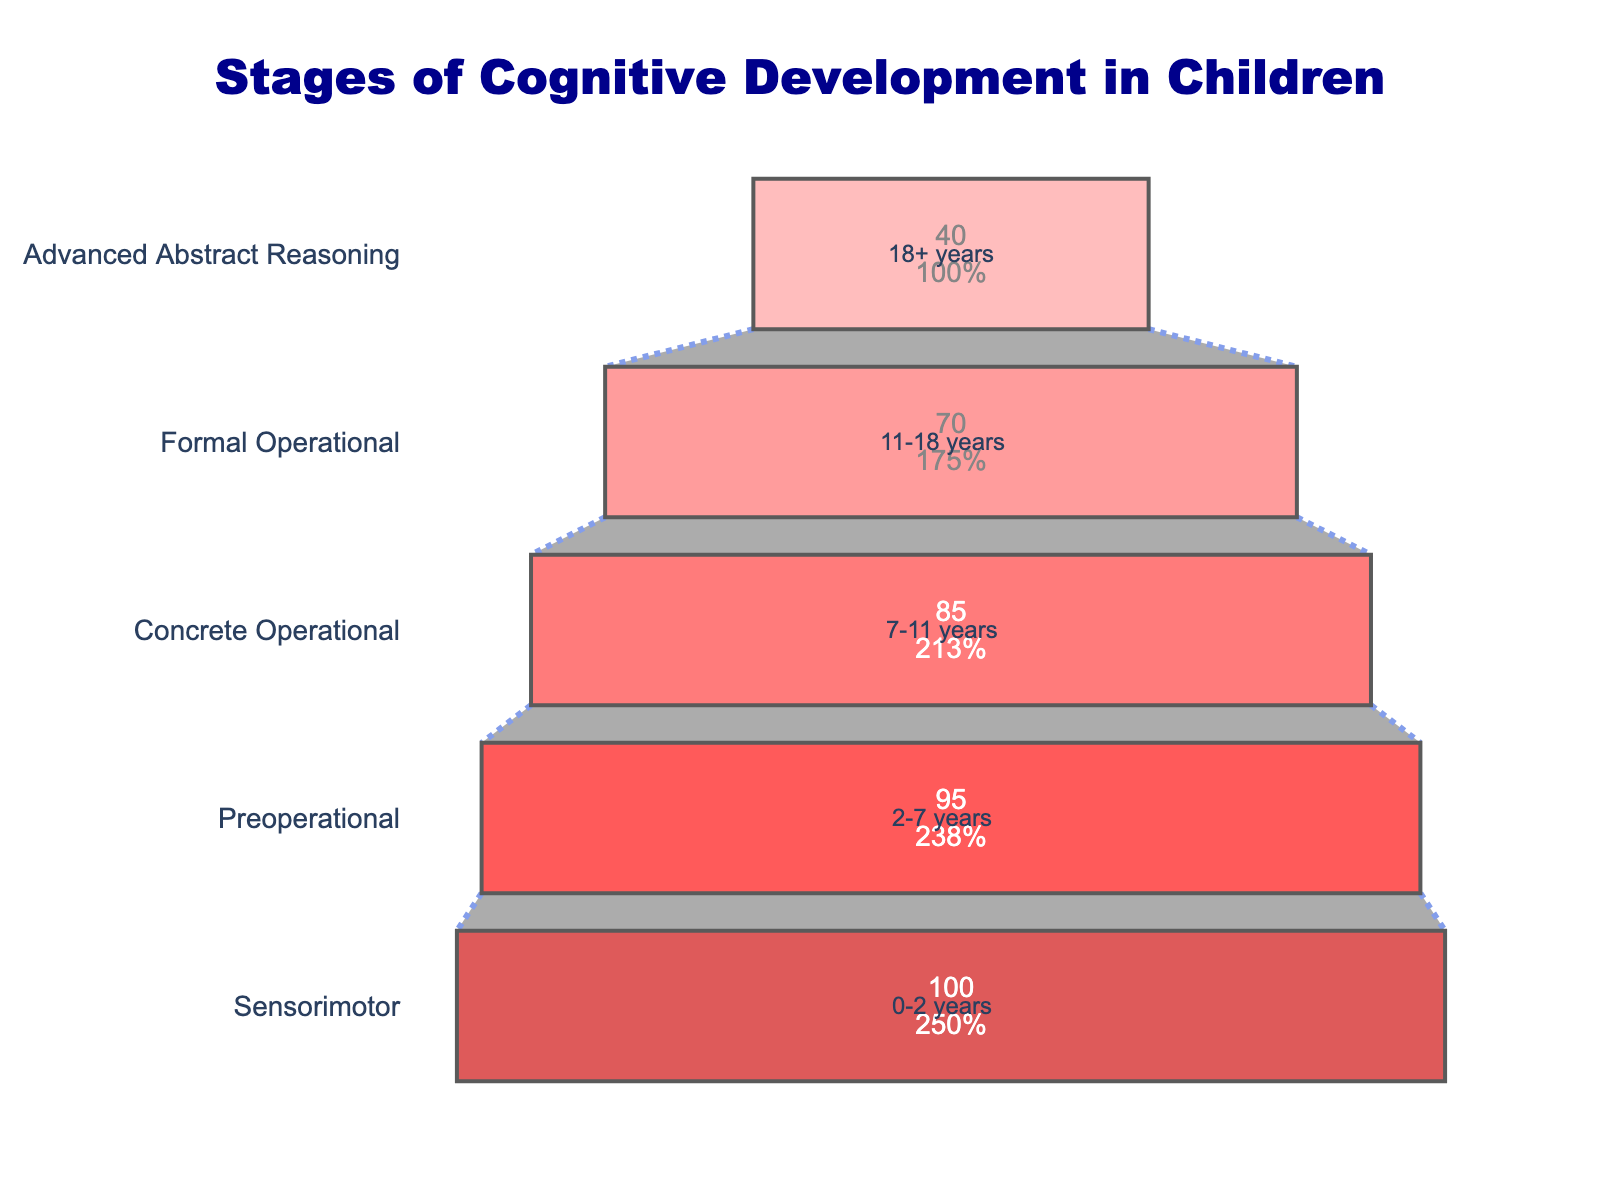What is the title of the funnel chart? The title is located at the top of the funnel chart in large, dark blue, bold font.
Answer: Stages of Cognitive Development in Children How many stages of cognitive development are shown in the funnel chart? Count the number of distinct stages listed on the left side of the funnel chart.
Answer: Five Which stage has the smallest percentage of children reaching it? Look for the stage with the lowest percentage on the funnel chart.
Answer: Advanced Abstract Reasoning What percentage of children reach the Preoperational stage? Identify the bar corresponding to the Preoperational stage and note the percentage inside the bar.
Answer: 95% What is the difference in percentage between children reaching the Concrete Operational stage and the Formal Operational stage? Subtract the percentage of children reaching the Formal Operational stage (70%) from the percentage of children reaching the Concrete Operational stage (85%).
Answer: 15% Which stages have more than 80% of children reaching them? Identify stages whose bars represent a percentage greater than 80%.
Answer: Sensorimotor, Preoperational, Concrete Operational Compare the percentage of children reaching the Sensorimotor stage and the Formal Operational stage. Which is higher and by how much? The Sensorimotor stage has 100% while the Formal Operational stage has 70%. Subtract 70 from 100 to find the difference.
Answer: Sensorimotor, 30% What percentage of children fail to reach the Advanced Abstract Reasoning stage? Subtract the percentage of children reaching the Advanced Abstract Reasoning stage (40%) from 100%.
Answer: 60% Rank the stages from the highest to the lowest percentage of children reaching them. Order the stages based on the percentages indicated inside the bars.
Answer: Sensorimotor, Preoperational, Concrete Operational, Formal Operational, Advanced Abstract Reasoning How does the percentage of children reaching the Formal Operational stage compare to those reaching the Sensorimotor stage? Compare the percentages directly from the chart. Sensorimotor has 100% while Formal Operational has 70%. The Formal Operational percentage is lower.
Answer: The Formal Operational stage is 30% lower 